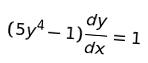Convert formula to latex. <formula><loc_0><loc_0><loc_500><loc_500>( 5 y ^ { 4 } - 1 ) \frac { d y } { d x } = 1</formula> 